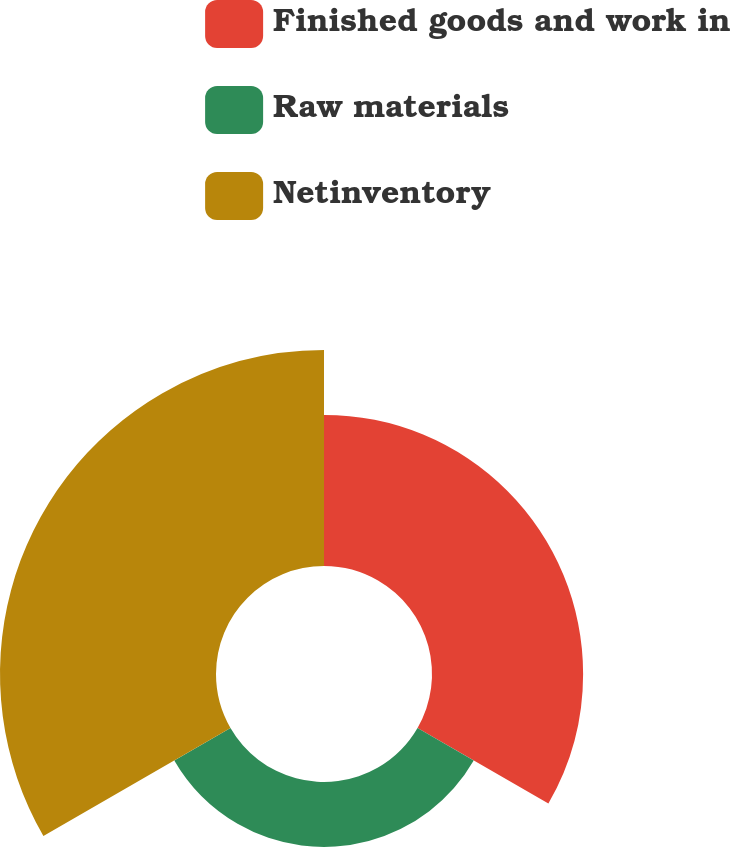Convert chart. <chart><loc_0><loc_0><loc_500><loc_500><pie_chart><fcel>Finished goods and work in<fcel>Raw materials<fcel>Netinventory<nl><fcel>34.98%<fcel>15.02%<fcel>50.0%<nl></chart> 